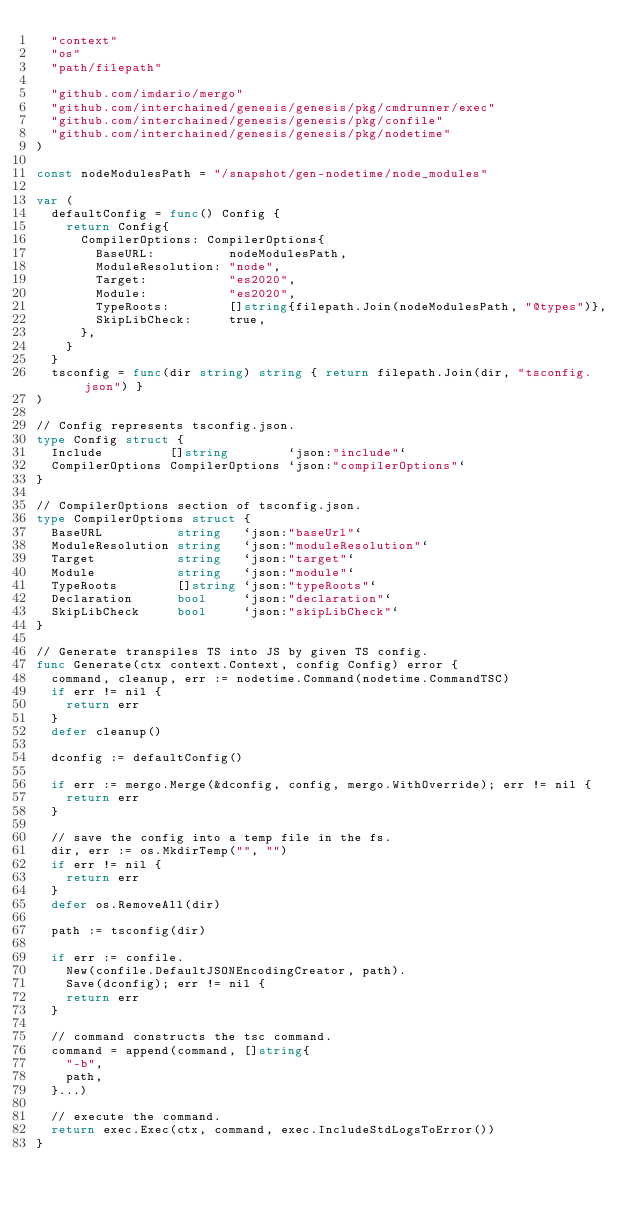<code> <loc_0><loc_0><loc_500><loc_500><_Go_>	"context"
	"os"
	"path/filepath"

	"github.com/imdario/mergo"
	"github.com/interchained/genesis/genesis/pkg/cmdrunner/exec"
	"github.com/interchained/genesis/genesis/pkg/confile"
	"github.com/interchained/genesis/genesis/pkg/nodetime"
)

const nodeModulesPath = "/snapshot/gen-nodetime/node_modules"

var (
	defaultConfig = func() Config {
		return Config{
			CompilerOptions: CompilerOptions{
				BaseURL:          nodeModulesPath,
				ModuleResolution: "node",
				Target:           "es2020",
				Module:           "es2020",
				TypeRoots:        []string{filepath.Join(nodeModulesPath, "@types")},
				SkipLibCheck:     true,
			},
		}
	}
	tsconfig = func(dir string) string { return filepath.Join(dir, "tsconfig.json") }
)

// Config represents tsconfig.json.
type Config struct {
	Include         []string        `json:"include"`
	CompilerOptions CompilerOptions `json:"compilerOptions"`
}

// CompilerOptions section of tsconfig.json.
type CompilerOptions struct {
	BaseURL          string   `json:"baseUrl"`
	ModuleResolution string   `json:"moduleResolution"`
	Target           string   `json:"target"`
	Module           string   `json:"module"`
	TypeRoots        []string `json:"typeRoots"`
	Declaration      bool     `json:"declaration"`
	SkipLibCheck     bool     `json:"skipLibCheck"`
}

// Generate transpiles TS into JS by given TS config.
func Generate(ctx context.Context, config Config) error {
	command, cleanup, err := nodetime.Command(nodetime.CommandTSC)
	if err != nil {
		return err
	}
	defer cleanup()

	dconfig := defaultConfig()

	if err := mergo.Merge(&dconfig, config, mergo.WithOverride); err != nil {
		return err
	}

	// save the config into a temp file in the fs.
	dir, err := os.MkdirTemp("", "")
	if err != nil {
		return err
	}
	defer os.RemoveAll(dir)

	path := tsconfig(dir)

	if err := confile.
		New(confile.DefaultJSONEncodingCreator, path).
		Save(dconfig); err != nil {
		return err
	}

	// command constructs the tsc command.
	command = append(command, []string{
		"-b",
		path,
	}...)

	// execute the command.
	return exec.Exec(ctx, command, exec.IncludeStdLogsToError())
}
</code> 